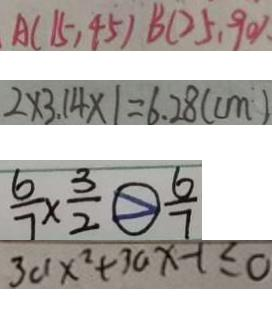<formula> <loc_0><loc_0><loc_500><loc_500>A ( 1 5 , 4 5 ) B ( 2 5 , 9 0 ) . 
 2 \times 3 . 1 4 \times 1 = 6 . 2 8 ( c m ) 
 \frac { 6 } { 7 } \times \frac { 3 } { 2 } > \frac { 6 } { 7 } 
 3 a x ^ { 2 } + 3 a x - 1 \leq 0</formula> 